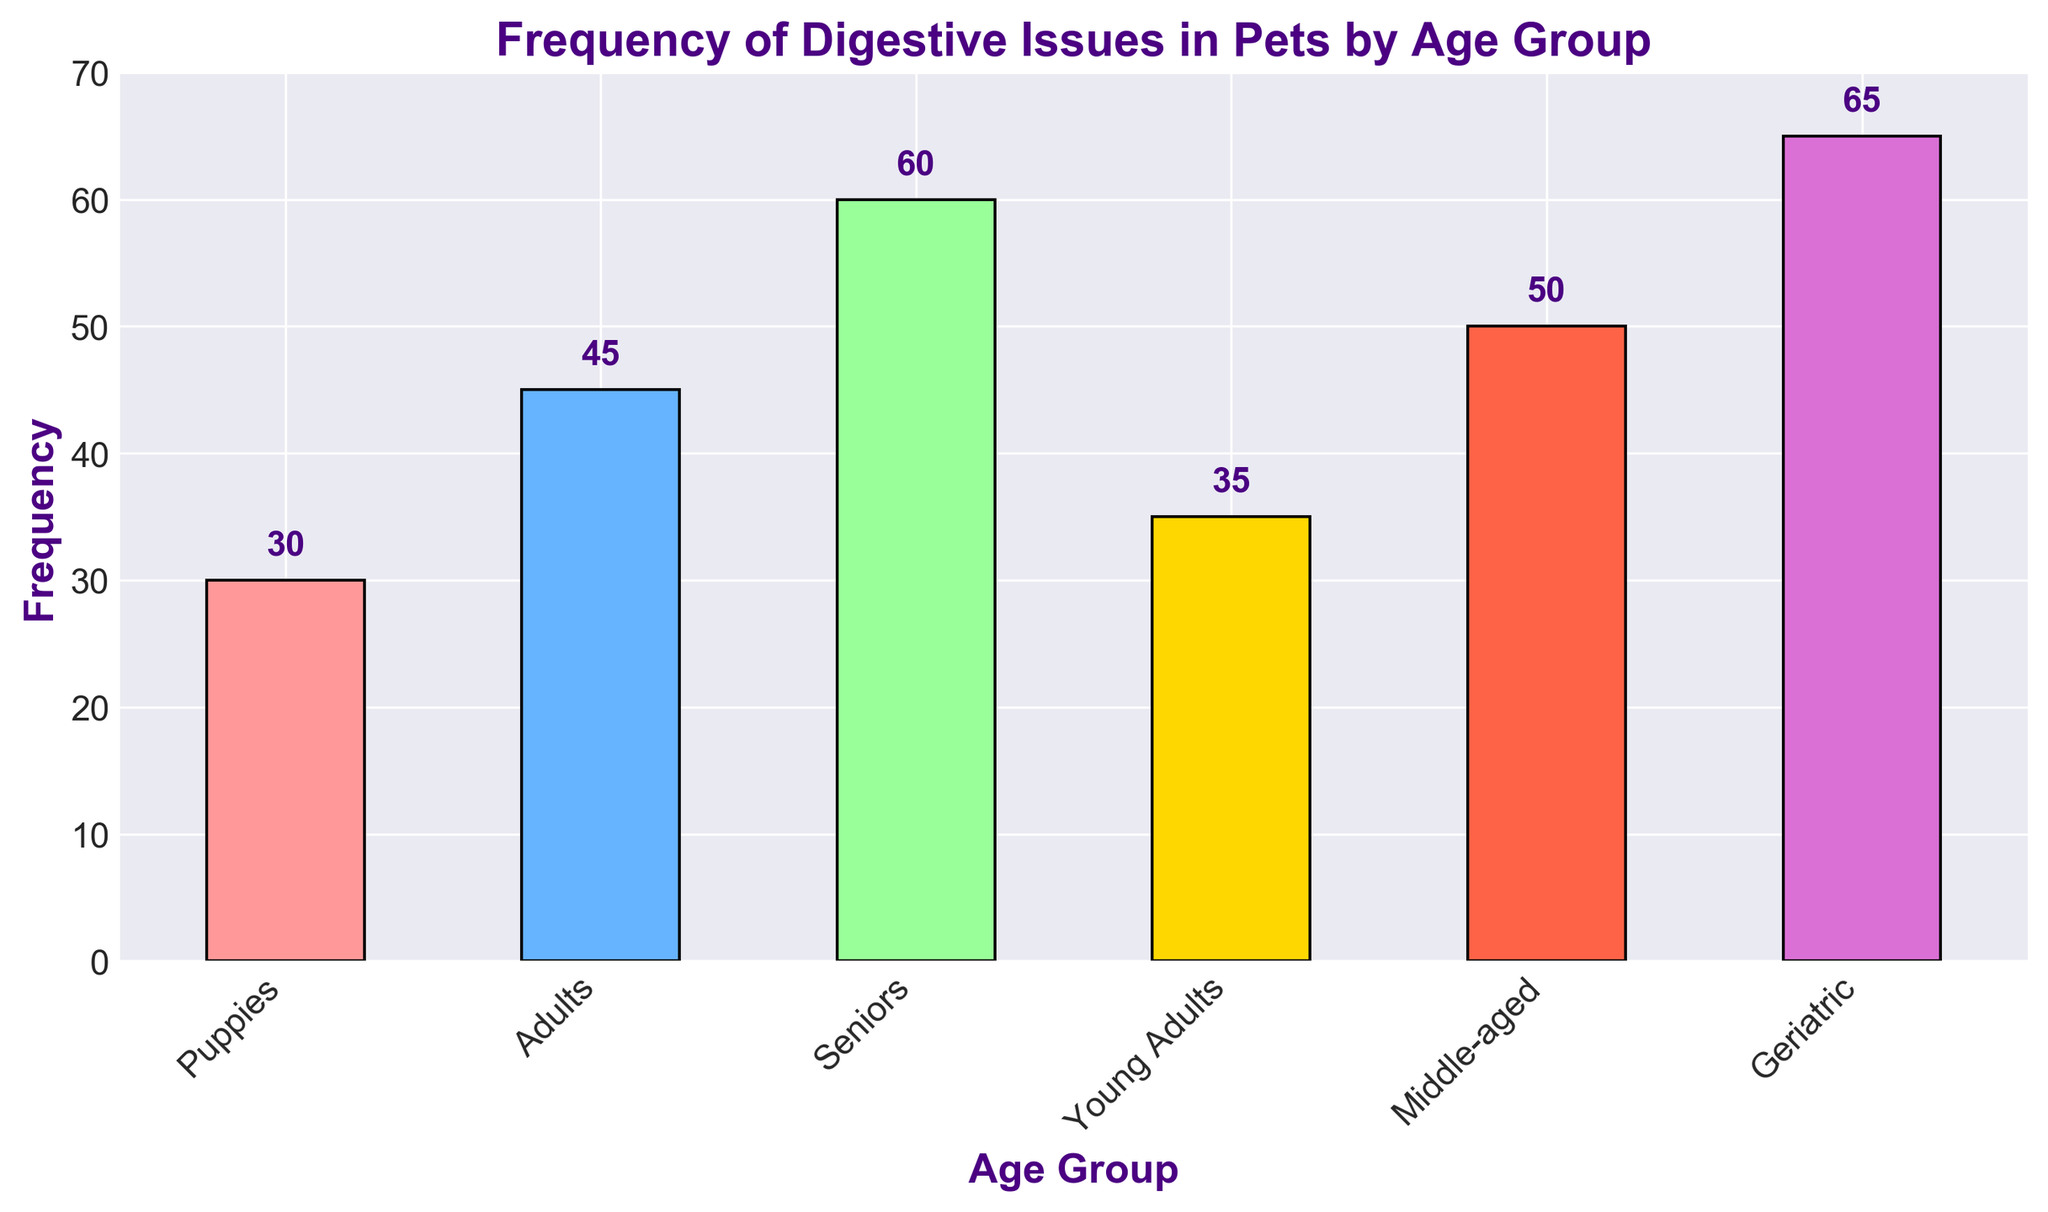What age group has the highest frequency of digestive issues? Look at the height of the bars in the chart and identify the one that is tallest. The tallest bar represents the Geriatric age group with a frequency of 65.
Answer: Geriatric How many more digestive issues do Seniors have compared to Puppies? Identify the frequencies for Seniors (60) and Puppies (30). Subtract the frequency for Puppies from that for Seniors: 60 - 30 = 30.
Answer: 30 Which age group has the least digestive issues? Look at the height of the bars and identify the one that is the shortest. The shortest bar represents the Puppies age group with a frequency of 30.
Answer: Puppies What is the average frequency of digestive issues across all age groups? Add up the frequencies for all age groups (30 + 45 + 60 + 35 + 50 + 65) and divide by the number of age groups (6). This gives (30 + 45 + 60 + 35 + 50 + 65) / 6 = 285 / 6 = 47.5.
Answer: 47.5 What is the sum of the frequencies for Adults and Middle-aged pets? Identify the frequencies for Adults (45) and Middle-aged (50). Add them together: 45 + 50 = 95.
Answer: 95 Which age group has a frequency closest to 50? Identify the frequencies of each group and find the one that is closest to 50. The Middle-aged group has a frequency of 50, which matches exactly.
Answer: Middle-aged Compare the frequency of digestive issues in Young Adults versus Adults. Which is higher and by how much? Identify the frequencies for Young Adults (35) and Adults (45). Subtract the frequency for Young Adults from that for Adults: 45 - 35 = 10.
Answer: Adults by 10 What are the colors used to represent the different age groups in the chart? Visually scan the chart and note down the colors used for each bar. The colors are light red, blue, light green, yellow, red, and pink.
Answer: Light red, blue, light green, yellow, red, pink How does the frequency of digestive issues in Seniors differ from Geriatric pets? Identify the frequencies for Seniors (60) and Geriatric pets (65). Subtract the frequency for Seniors from that for Geriatric pets: 65 - 60 = 5.
Answer: Geriatric by 5 